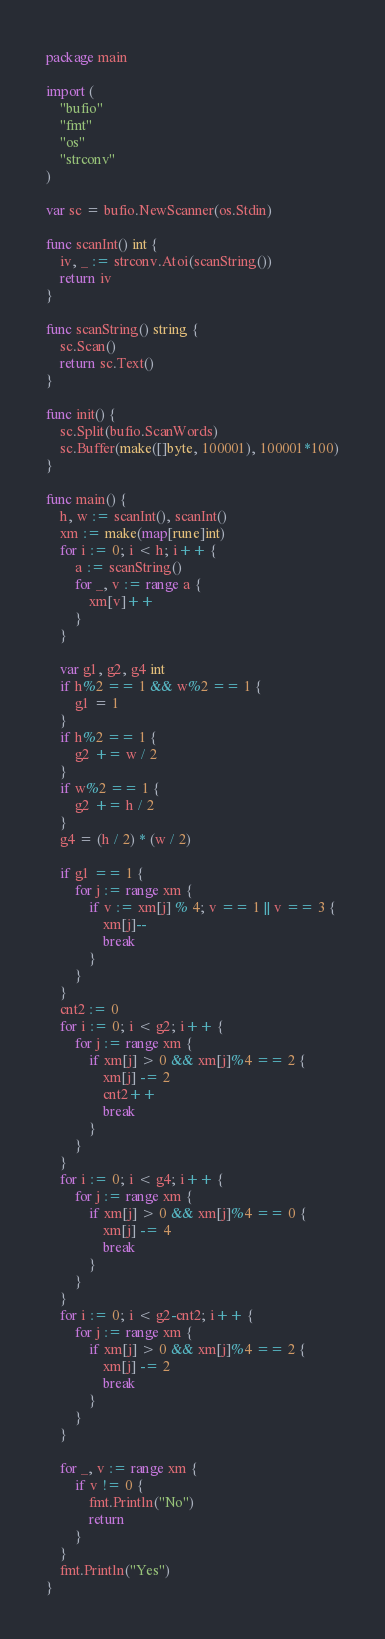Convert code to text. <code><loc_0><loc_0><loc_500><loc_500><_Go_>package main

import (
	"bufio"
	"fmt"
	"os"
	"strconv"
)

var sc = bufio.NewScanner(os.Stdin)

func scanInt() int {
	iv, _ := strconv.Atoi(scanString())
	return iv
}

func scanString() string {
	sc.Scan()
	return sc.Text()
}

func init() {
	sc.Split(bufio.ScanWords)
	sc.Buffer(make([]byte, 100001), 100001*100)
}

func main() {
	h, w := scanInt(), scanInt()
	xm := make(map[rune]int)
	for i := 0; i < h; i++ {
		a := scanString()
		for _, v := range a {
			xm[v]++
		}
	}

	var g1, g2, g4 int
	if h%2 == 1 && w%2 == 1 {
		g1 = 1
	}
	if h%2 == 1 {
		g2 += w / 2
	}
	if w%2 == 1 {
		g2 += h / 2
	}
	g4 = (h / 2) * (w / 2)

	if g1 == 1 {
		for j := range xm {
			if v := xm[j] % 4; v == 1 || v == 3 {
				xm[j]--
				break
			}
		}
	}
	cnt2 := 0
	for i := 0; i < g2; i++ {
		for j := range xm {
			if xm[j] > 0 && xm[j]%4 == 2 {
				xm[j] -= 2
				cnt2++
				break
			}
		}
	}
	for i := 0; i < g4; i++ {
		for j := range xm {
			if xm[j] > 0 && xm[j]%4 == 0 {
				xm[j] -= 4
				break
			}
		}
	}
	for i := 0; i < g2-cnt2; i++ {
		for j := range xm {
			if xm[j] > 0 && xm[j]%4 == 2 {
				xm[j] -= 2
				break
			}
		}
	}

	for _, v := range xm {
		if v != 0 {
			fmt.Println("No")
			return
		}
	}
	fmt.Println("Yes")
}
</code> 